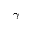Convert formula to latex. <formula><loc_0><loc_0><loc_500><loc_500>\gamma</formula> 